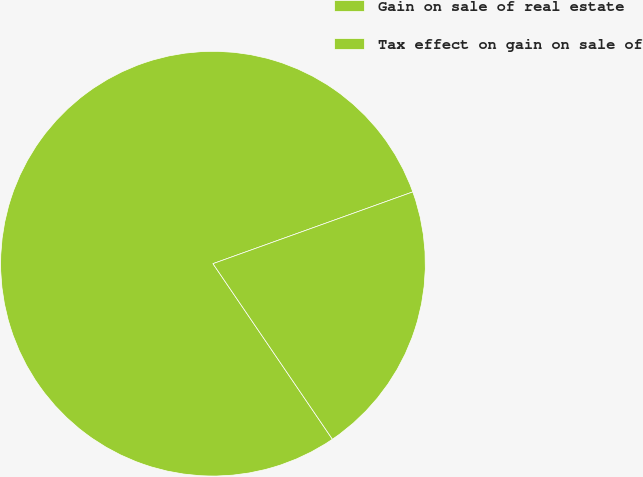Convert chart to OTSL. <chart><loc_0><loc_0><loc_500><loc_500><pie_chart><fcel>Gain on sale of real estate<fcel>Tax effect on gain on sale of<nl><fcel>79.02%<fcel>20.98%<nl></chart> 